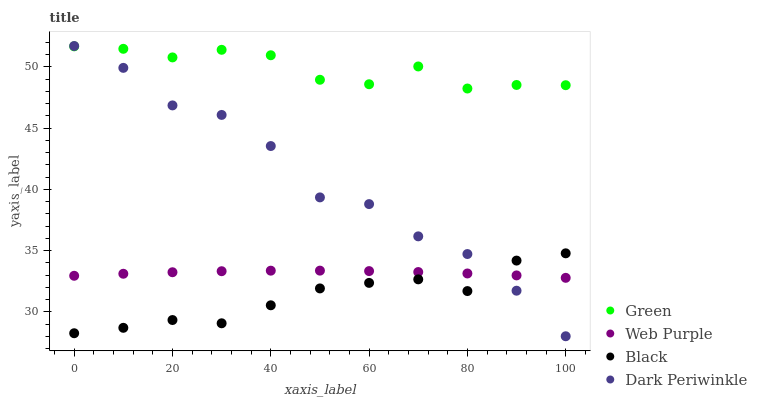Does Black have the minimum area under the curve?
Answer yes or no. Yes. Does Green have the maximum area under the curve?
Answer yes or no. Yes. Does Web Purple have the minimum area under the curve?
Answer yes or no. No. Does Web Purple have the maximum area under the curve?
Answer yes or no. No. Is Web Purple the smoothest?
Answer yes or no. Yes. Is Dark Periwinkle the roughest?
Answer yes or no. Yes. Is Green the smoothest?
Answer yes or no. No. Is Green the roughest?
Answer yes or no. No. Does Dark Periwinkle have the lowest value?
Answer yes or no. Yes. Does Web Purple have the lowest value?
Answer yes or no. No. Does Dark Periwinkle have the highest value?
Answer yes or no. Yes. Does Green have the highest value?
Answer yes or no. No. Is Web Purple less than Green?
Answer yes or no. Yes. Is Green greater than Web Purple?
Answer yes or no. Yes. Does Web Purple intersect Dark Periwinkle?
Answer yes or no. Yes. Is Web Purple less than Dark Periwinkle?
Answer yes or no. No. Is Web Purple greater than Dark Periwinkle?
Answer yes or no. No. Does Web Purple intersect Green?
Answer yes or no. No. 